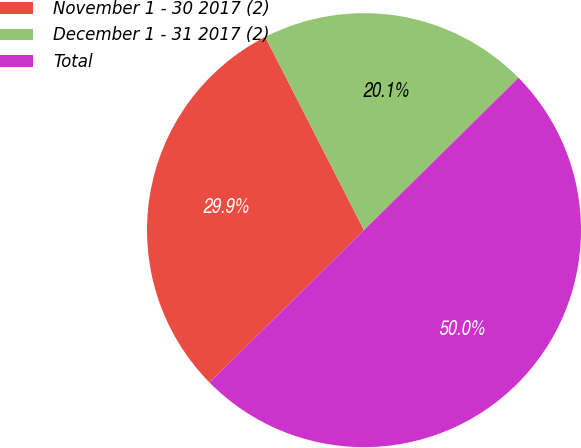<chart> <loc_0><loc_0><loc_500><loc_500><pie_chart><fcel>November 1 - 30 2017 (2)<fcel>December 1 - 31 2017 (2)<fcel>Total<nl><fcel>29.87%<fcel>20.13%<fcel>50.0%<nl></chart> 